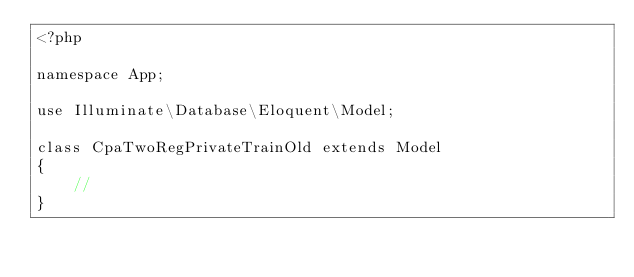<code> <loc_0><loc_0><loc_500><loc_500><_PHP_><?php

namespace App;

use Illuminate\Database\Eloquent\Model;

class CpaTwoRegPrivateTrainOld extends Model
{
    //
}
</code> 